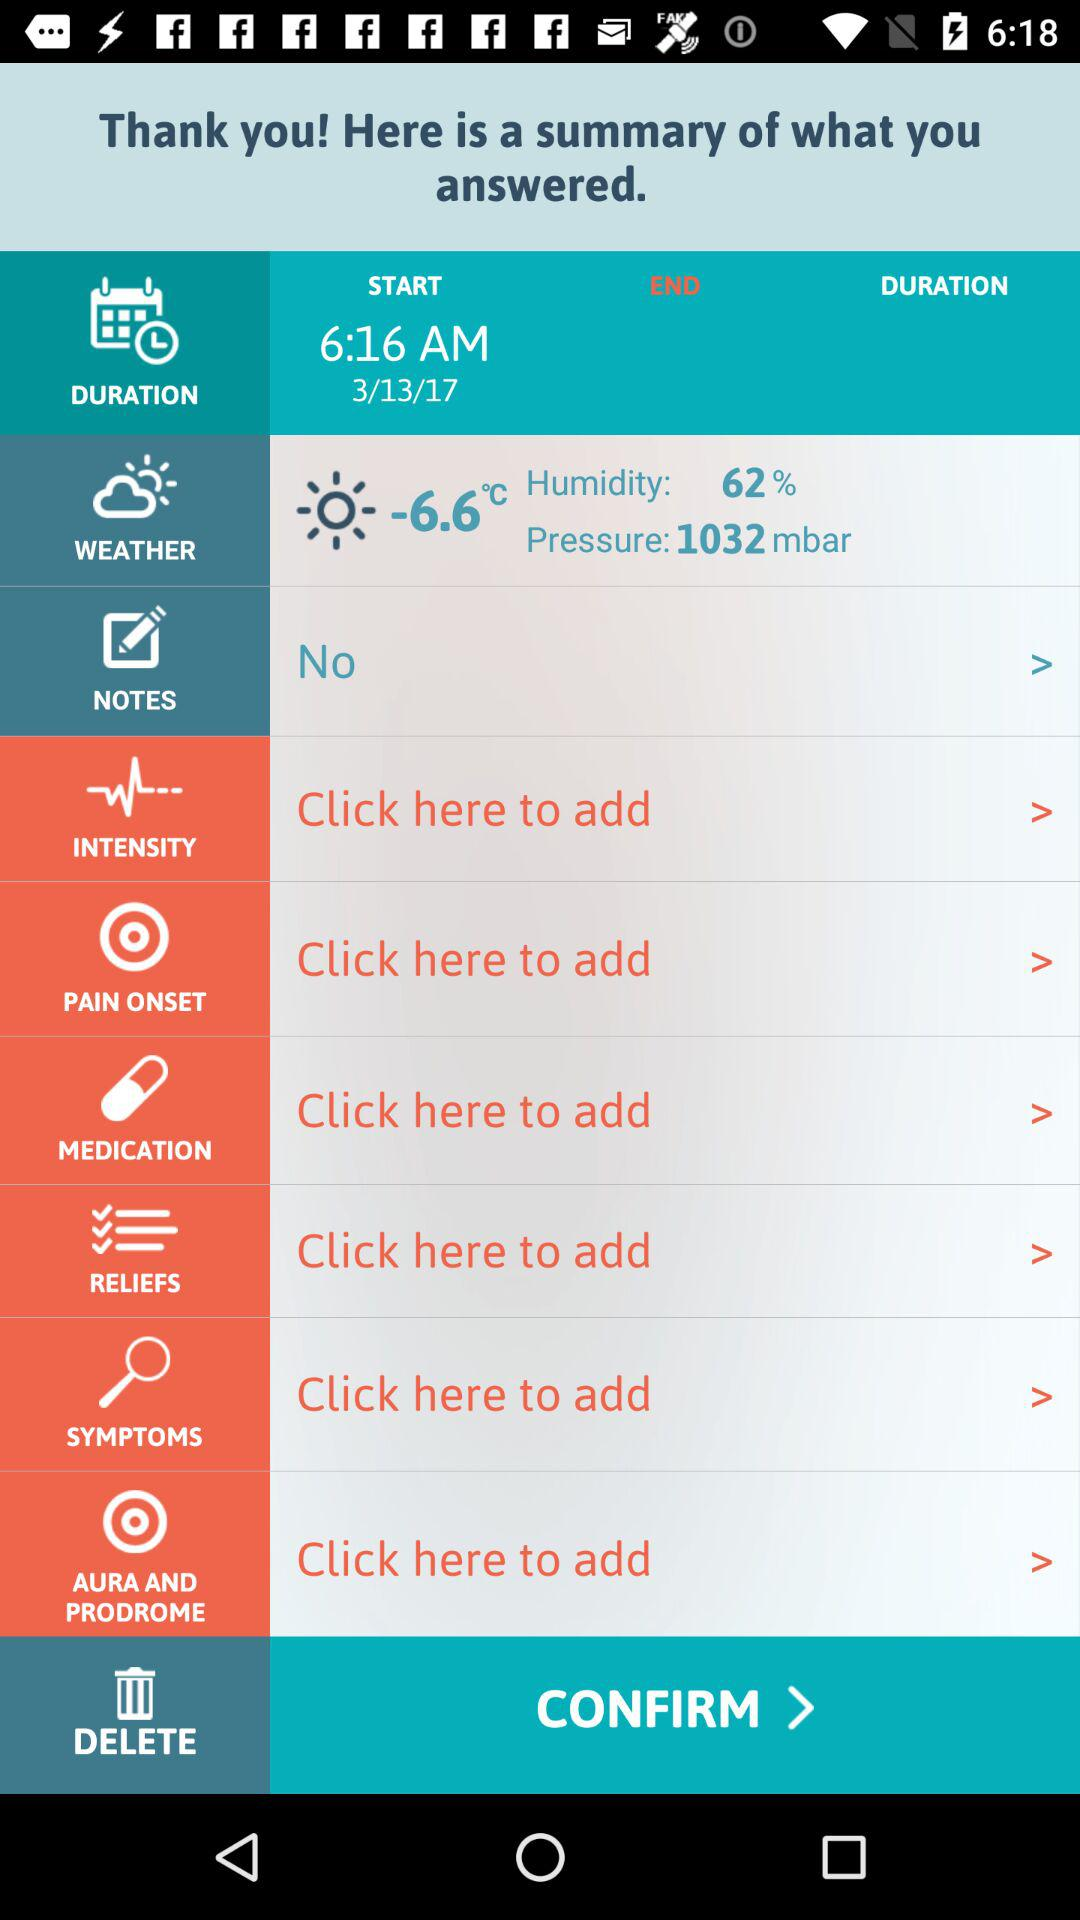What is the date? The date is March 13, 2017. 